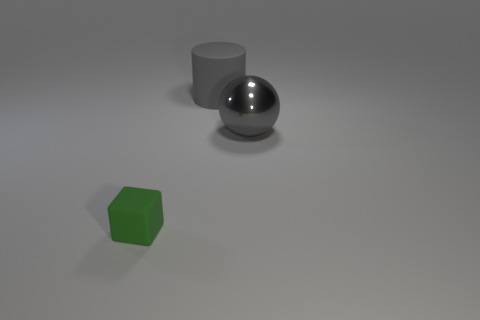Subtract all blocks. How many objects are left? 2 Subtract 1 balls. How many balls are left? 0 Subtract all purple spheres. Subtract all purple cylinders. How many spheres are left? 1 Subtract all purple cylinders. How many red cubes are left? 0 Subtract all small blocks. Subtract all brown objects. How many objects are left? 2 Add 1 tiny matte objects. How many tiny matte objects are left? 2 Add 1 gray metallic objects. How many gray metallic objects exist? 2 Add 1 large cyan shiny cylinders. How many objects exist? 4 Subtract 1 gray cylinders. How many objects are left? 2 